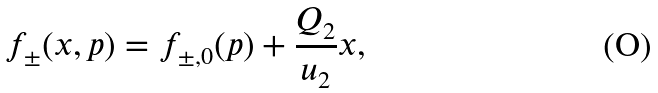<formula> <loc_0><loc_0><loc_500><loc_500>f _ { \pm } ( x , p ) = f _ { \pm , 0 } ( p ) + \frac { Q _ { 2 } } { u _ { 2 } } x ,</formula> 